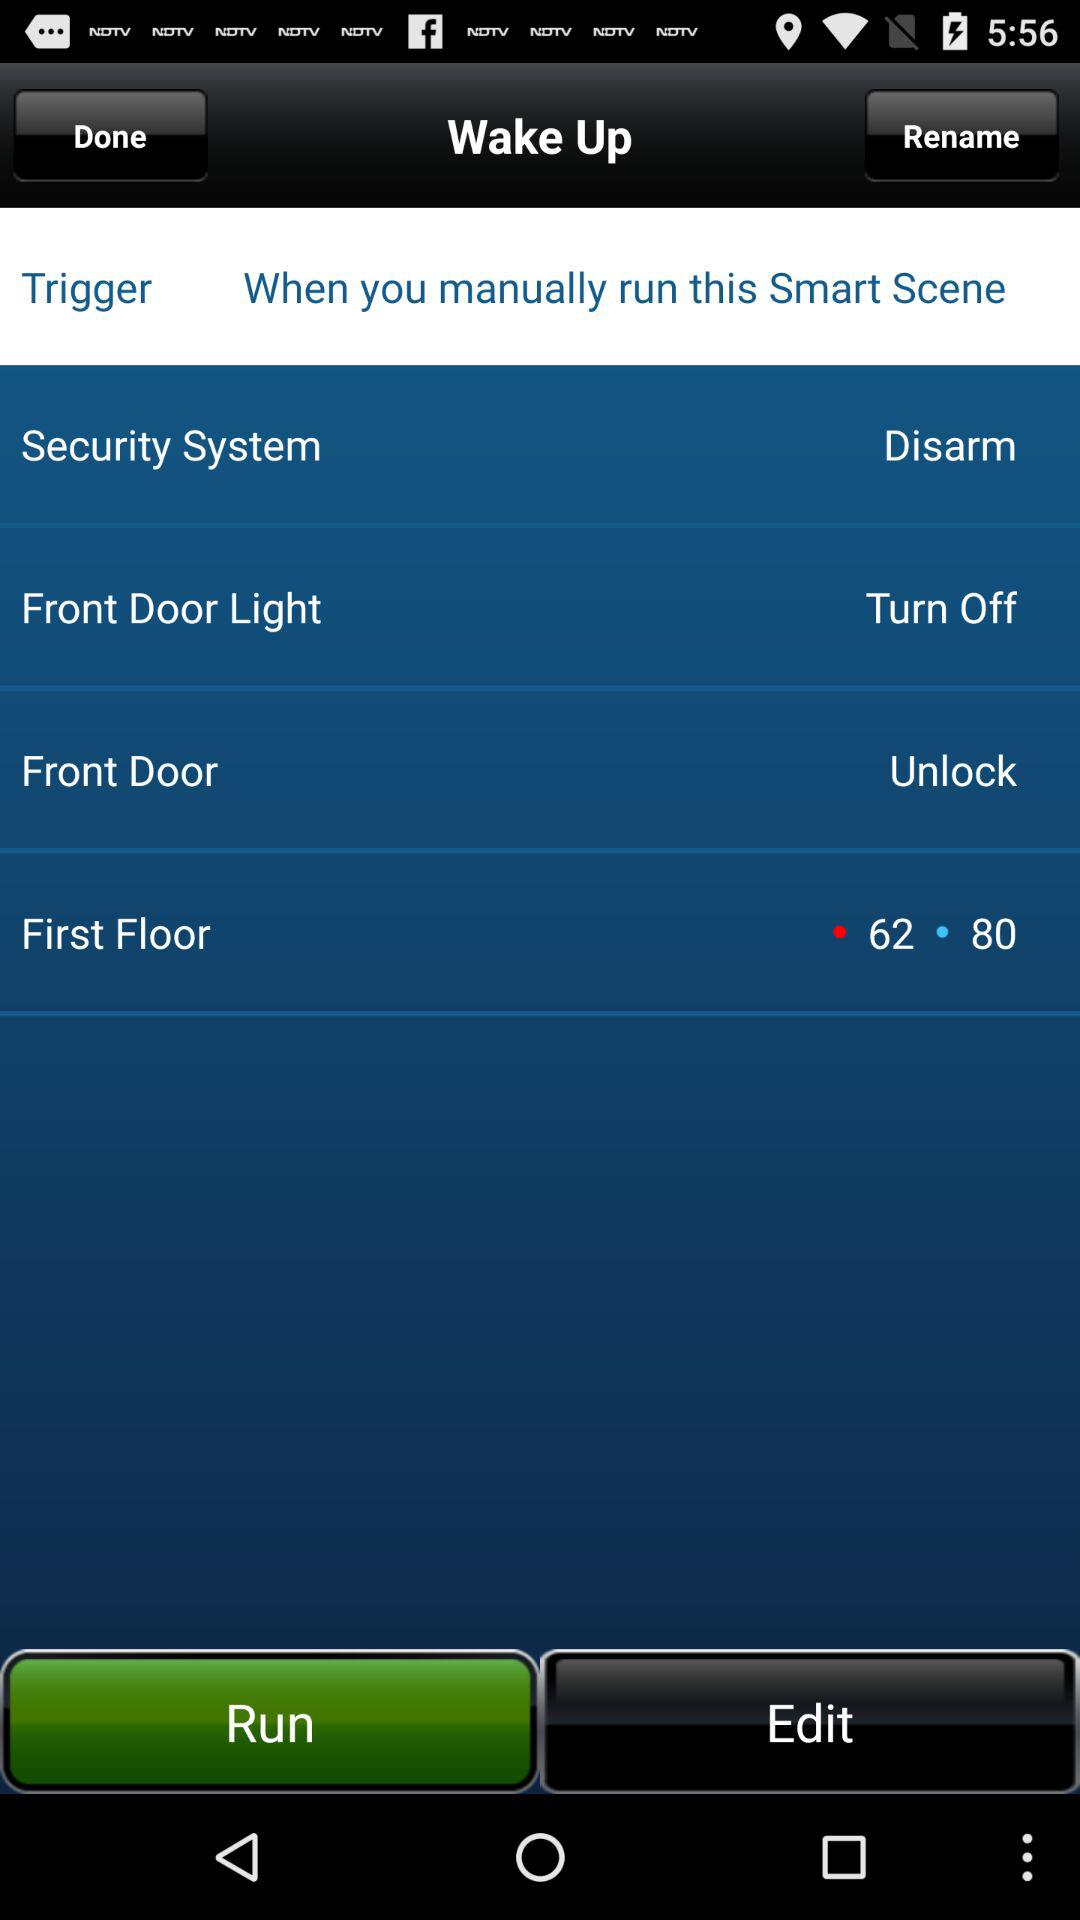What is the status of "Front Door"? The status of "Front Door" is "Unlock". 